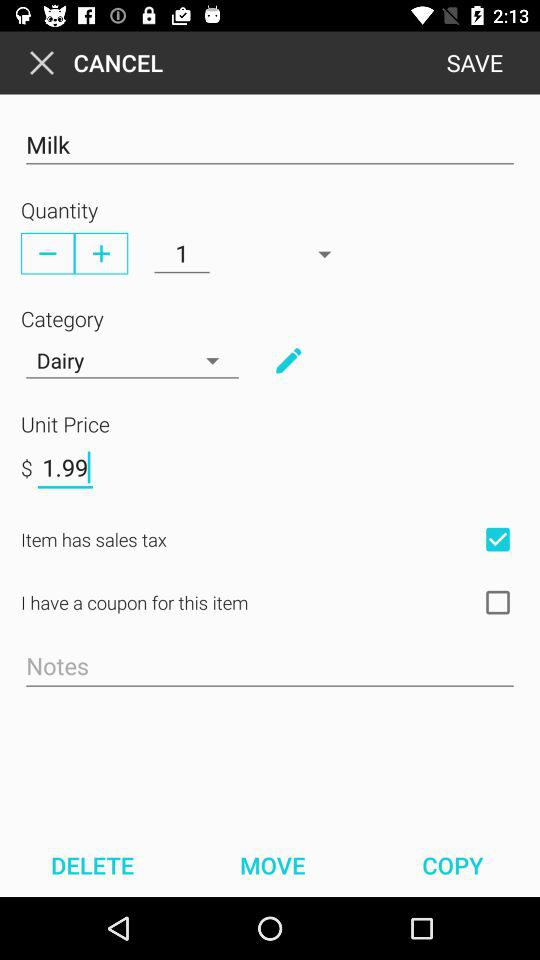What is the unit price of the item?
Answer the question using a single word or phrase. 1.99 